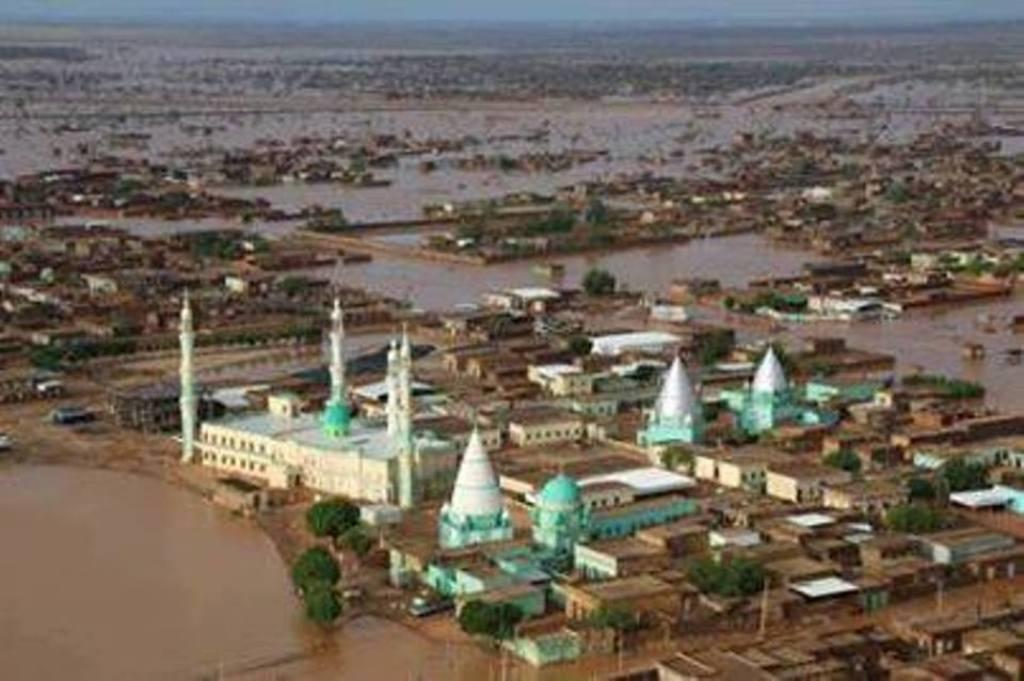What type of structures can be seen in the image? There are buildings in the image. What type of vegetation is present in the image? There are trees in the image. What natural element is visible in the image? There is water visible in the image. What part of the natural environment is visible in the background of the image? The sky is visible in the background of the image. Can you tell me how many horses are present in the image? There are no horses present in the image. What type of animal can be seen interacting with the buildings in the image? There are no animals interacting with the buildings in the image. 